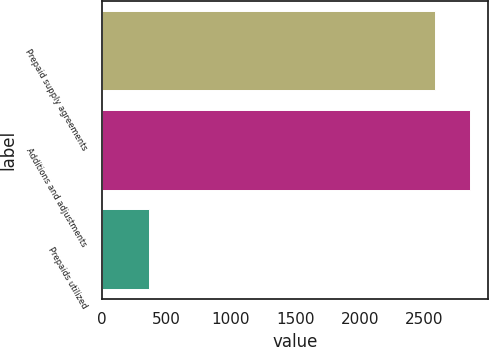Convert chart. <chart><loc_0><loc_0><loc_500><loc_500><bar_chart><fcel>Prepaid supply agreements<fcel>Additions and adjustments<fcel>Prepaids utilized<nl><fcel>2587<fcel>2851.8<fcel>369.8<nl></chart> 